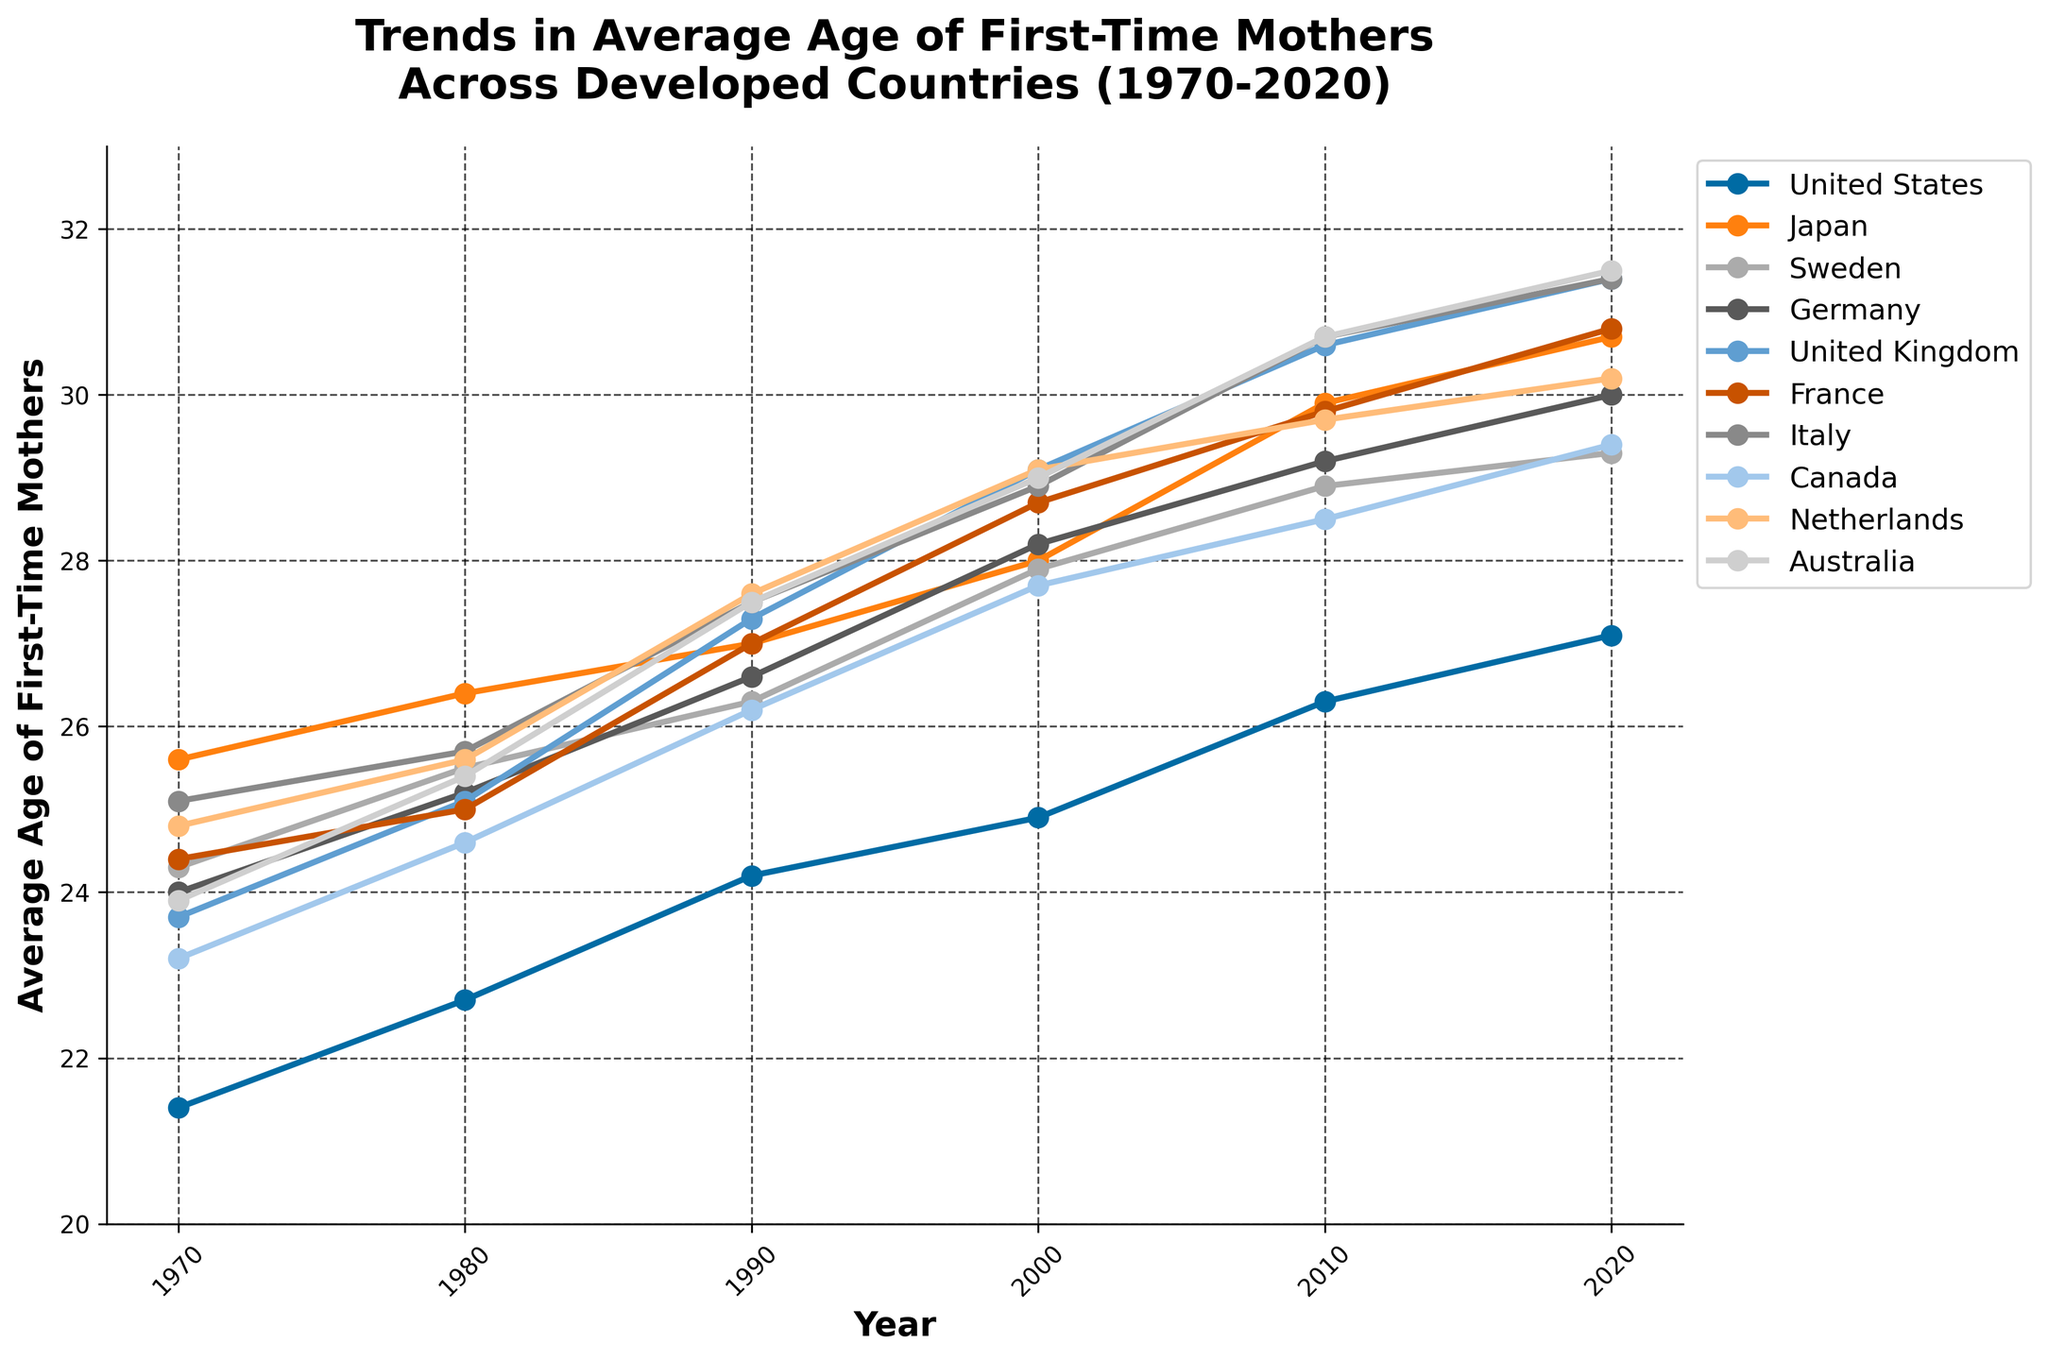Which country experienced the greatest increase in the average age of first-time mothers from 1970 to 2020? Calculate the increase for each country by subtracting the 1970 value from the 2020 value. United States: 27.1 - 21.4 = 5.7, Japan: 30.7 - 25.6 = 5.1, Sweden: 29.3 - 24.3 = 5.0, Germany: 30.0 - 24.0 = 6.0, United Kingdom: 31.4 - 23.7 = 7.7, France: 30.8 - 24.4 = 6.4, Italy: 31.4 - 25.1 = 6.3, Canada: 29.4 - 23.2 = 6.2, Netherlands: 30.2 - 24.8 = 5.4, Australia: 31.5 - 23.9 = 7.6. Therefore, the United Kingdom experienced the greatest increase.
Answer: United Kingdom In what year did France surpass an average age of 28 for first-time mothers? Check the data points for France and identify the first year in which the value exceeds 28. The value crosses 28 in the year 2000, where it is 28.7.
Answer: 2000 How does the average age of first-time mothers in Australia in 2020 compare to the average age in Japan in 1970? Look at the value for Australia in 2020 and compare it to Japan in 1970: Australia 2020 is 31.5, Japan 1970 is 25.6. Australia’s average age in 2020 is higher than Japan's in 1970.
Answer: Higher What is the average age of first-time mothers in Sweden in the year 2000? Locate the data point for Sweden in the year 2000 on the chart. The value is 27.9.
Answer: 27.9 Which country had the lowest average age of first-time mothers in the year 1970? Compare the average age of first-time mothers for all countries in 1970. The lowest value is for the United States at 21.4.
Answer: United States Has the average age of first-time mothers in Italy ever surpassed 30? If yes, in which years? Look at the data points for Italy and identify the years where the value exceeds 30. The values surpass 30 in the years 2010 (30.7) and 2020 (31.4).
Answer: 2010 and 2020 What is the difference in the average age of first-time mothers between the United Kingdom and Germany in the year 2020? Subtract the value for Germany from the value for the United Kingdom in 2020. United Kingdom: 31.4, Germany: 30.0. The difference is 31.4 - 30.0 = 1.4.
Answer: 1.4 In which decade did Japan see its highest increase in the average age of first-time mothers? Calculate the difference between each decade for Japan: 
1970-1980: 26.4 - 25.6 = 0.8 
1980-1990: 27.0 - 26.4 = 0.6 
1990-2000: 28.0 - 27.0 = 1.0 
2000-2010: 29.9 - 28.0 = 1.9 
2010-2020: 30.7 - 29.9 = 0.8 
The highest increase was between 2000 and 2010.
Answer: 2000-2010 What was the overall trend in the average age of first-time mothers in Canada from 1970 to 2020? Observe the data values for Canada over the years: from 23.2 in 1970, steadily increasing to 29.4 in 2020. The overall trend is an increase in the average age.
Answer: Increasing 